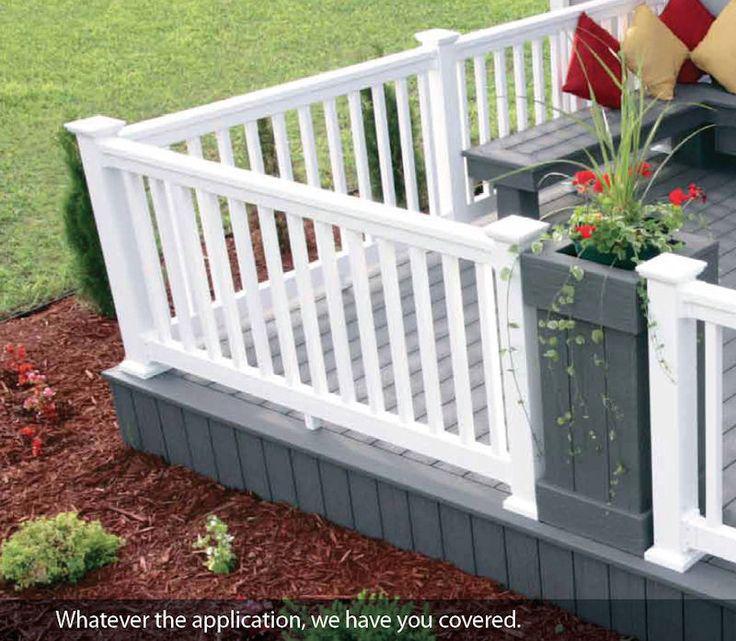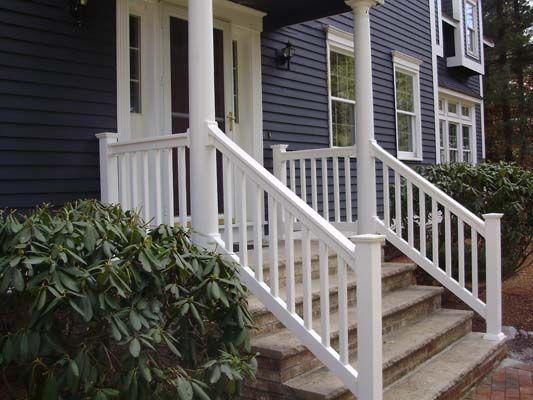The first image is the image on the left, the second image is the image on the right. Assess this claim about the two images: "At least one railing is white.". Correct or not? Answer yes or no. Yes. The first image is the image on the left, the second image is the image on the right. Given the left and right images, does the statement "The left image contains a deck with unpainted wood rails with mesh sides, and the right image shows a deck with light painted vertical rails with square-capped posts." hold true? Answer yes or no. No. 